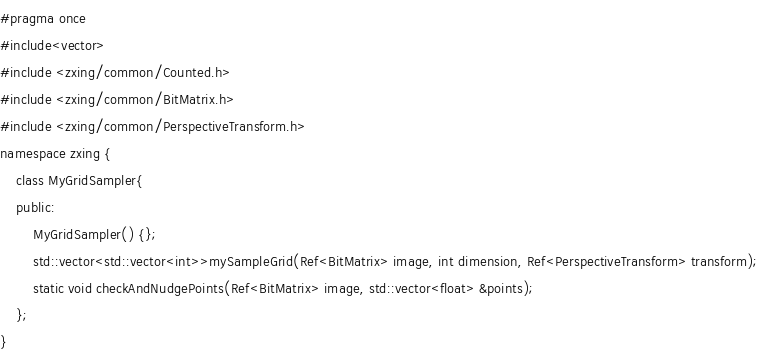<code> <loc_0><loc_0><loc_500><loc_500><_C_>#pragma once
#include<vector>
#include <zxing/common/Counted.h>
#include <zxing/common/BitMatrix.h>
#include <zxing/common/PerspectiveTransform.h>
namespace zxing {
	class MyGridSampler{
	public:
		MyGridSampler() {};
		std::vector<std::vector<int>>mySampleGrid(Ref<BitMatrix> image, int dimension, Ref<PerspectiveTransform> transform);
		static void checkAndNudgePoints(Ref<BitMatrix> image, std::vector<float> &points);
	};
}</code> 